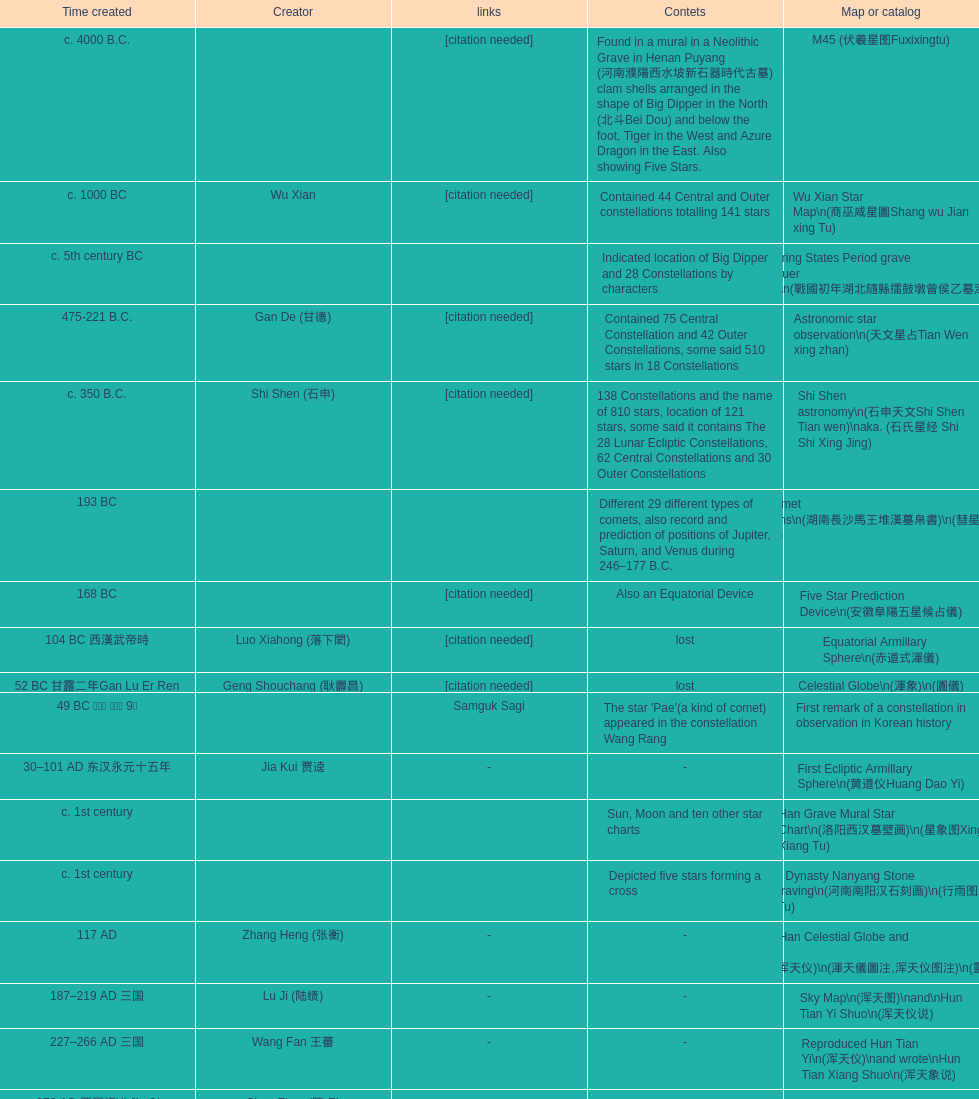What is the name of the oldest map/catalog? M45. 